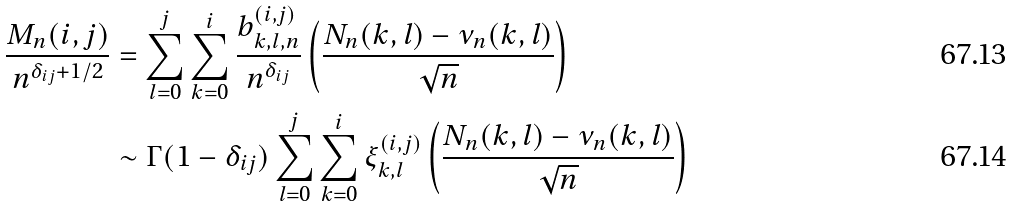Convert formula to latex. <formula><loc_0><loc_0><loc_500><loc_500>\frac { M _ { n } ( i , j ) } { n ^ { \delta _ { i j } + 1 / 2 } } & = \sum _ { l = 0 } ^ { j } \sum _ { k = 0 } ^ { i } \frac { b _ { k , l , n } ^ { ( i , j ) } } { n ^ { \delta _ { i j } } } \left ( \frac { N _ { n } ( k , l ) - \nu _ { n } ( k , l ) } { \sqrt { n } } \right ) \\ & \sim \Gamma ( 1 - \delta _ { i j } ) \sum _ { l = 0 } ^ { j } \sum _ { k = 0 } ^ { i } \xi _ { k , l } ^ { ( i , j ) } \left ( \frac { N _ { n } ( k , l ) - \nu _ { n } ( k , l ) } { \sqrt { n } } \right )</formula> 